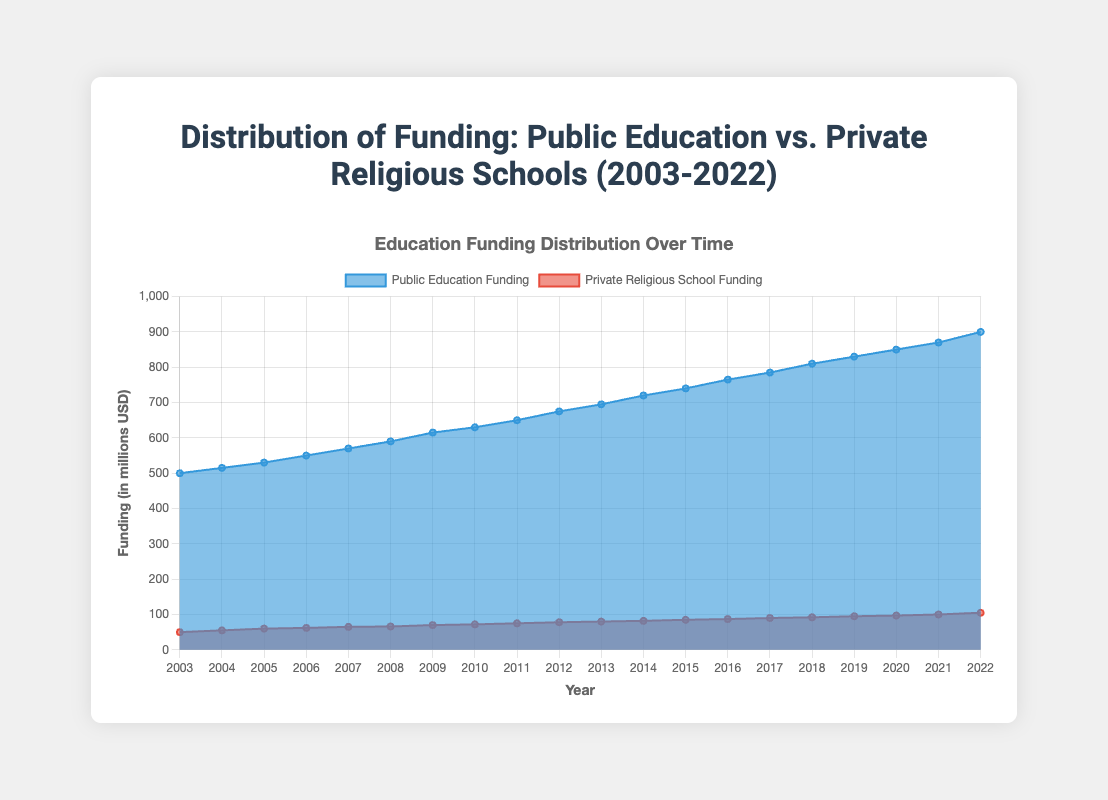What's the title of the chart? The title is displayed at the top of the chart. Refer to the text in a larger and bold font.
Answer: Distribution of Funding: Public Education vs. Private Religious Schools (2003-2022) How many years are displayed on the chart? Count the number of data points along the x-axis labeled with the years.
Answer: 20 What is the funding amount for public education in 2012? Find the 2012 mark on the x-axis, then check the corresponding point on the public education funding line.
Answer: 675 million USD How does the trend of public education funding compare to that of private religious school funding from 2003 to 2022? Observe both lines spanning over the period from 2003 to 2022 and compare their slopes and overall increases.
Answer: Public education funding steadily increases more significantly than private religious school funding In which year did private religious school funding reach 100 million USD? Identify the point on the private religious school funding line that hits 100 million USD, and trace vertically to the x-axis for the year.
Answer: 2021 What is the average funding amount for private religious schools from 2003 to 2022? Sum all the funding values for private religious schools and divide by the number of years (20).
Answer: (50 + 55 + 60 + 62 + 65 + 66 + 70 + 72 + 75 + 78 + 80 + 82 + 85 + 87 + 90 + 92 + 95 + 97 + 100 + 105) / 20 = 75 million USD Which year shows the smallest difference between public education funding and private religious school funding? Calculate the funding differences between public and private religious schools for each year and find the year with the smallest value.
Answer: 2003 By how much did public education funding increase from 2003 to 2022? Subtract the public education funding amount in 2003 from the amount in 2022.
Answer: 900 million USD - 500 million USD = 400 million USD During which period did both public education and private religious school funding increase the most? Look for the period where both funding lines have the steepest positive slope.
Answer: The period from 2007 to 2012 What is the general trend observed for both public education and private religious school funding over the last 20 years? Interpret the overall slopes and directions of both lines over the entire period shown in the chart.
Answer: Both public education and private religious school funding show a general upward trend 